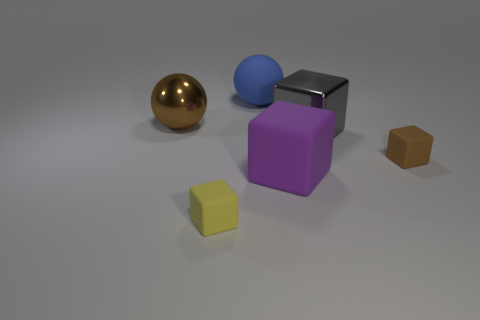Imagine these objects are part of a game, which one would be the most valuable and why? In a hypothetical game, the metallic ball might be the most valuable due to its shiny, eye-catching appearance which could indicate a higher in-game status or value. 